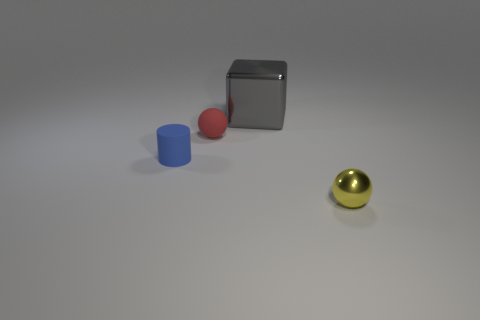Is there any other thing that has the same size as the gray cube?
Ensure brevity in your answer.  No. How many big things are red balls or metal things?
Provide a succinct answer. 1. Is there a big gray object that has the same shape as the blue thing?
Provide a succinct answer. No. Is the shape of the small blue object the same as the yellow object?
Provide a short and direct response. No. What color is the metallic object in front of the small matte thing in front of the rubber ball?
Give a very brief answer. Yellow. There is a shiny ball that is the same size as the cylinder; what is its color?
Make the answer very short. Yellow. How many matte objects are either large green cylinders or gray things?
Give a very brief answer. 0. There is a object to the left of the tiny red rubber sphere; how many small cylinders are on the left side of it?
Your answer should be compact. 0. What number of objects are either small yellow metallic spheres or things that are to the left of the tiny yellow thing?
Offer a terse response. 4. Is there a thing made of the same material as the yellow ball?
Your answer should be compact. Yes. 